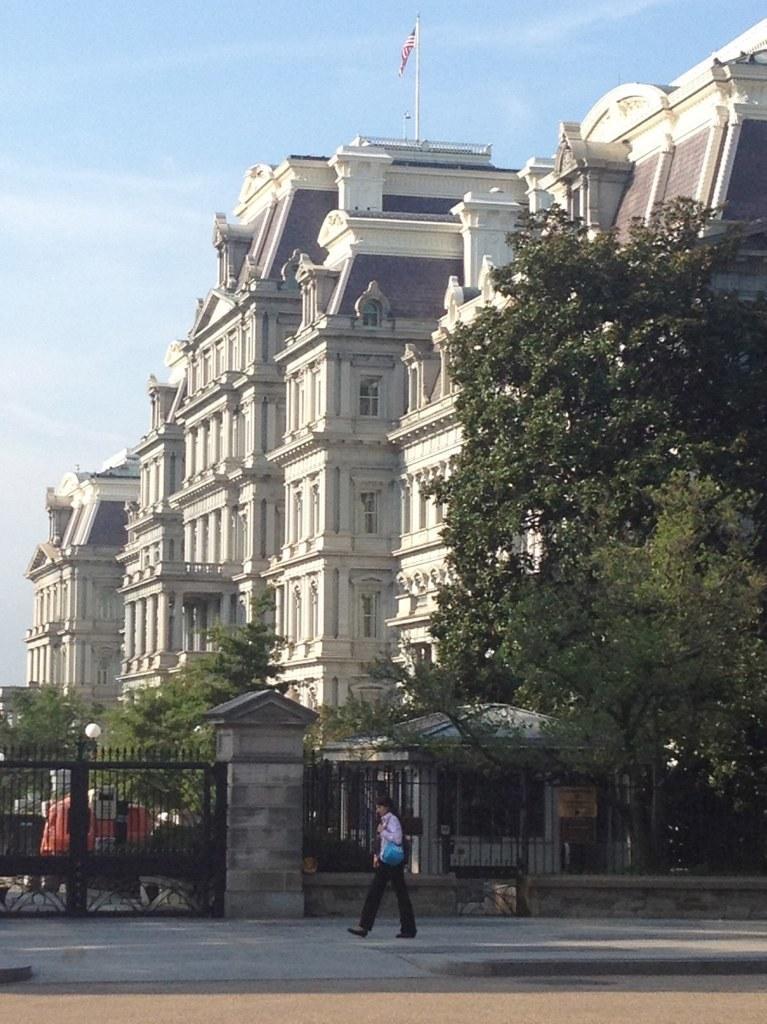Please provide a concise description of this image. In this picture I can see a person at the bottom, there is a gate and the iron grill. In the background there are trees and buildings, at the top there is the flag and the sky. 